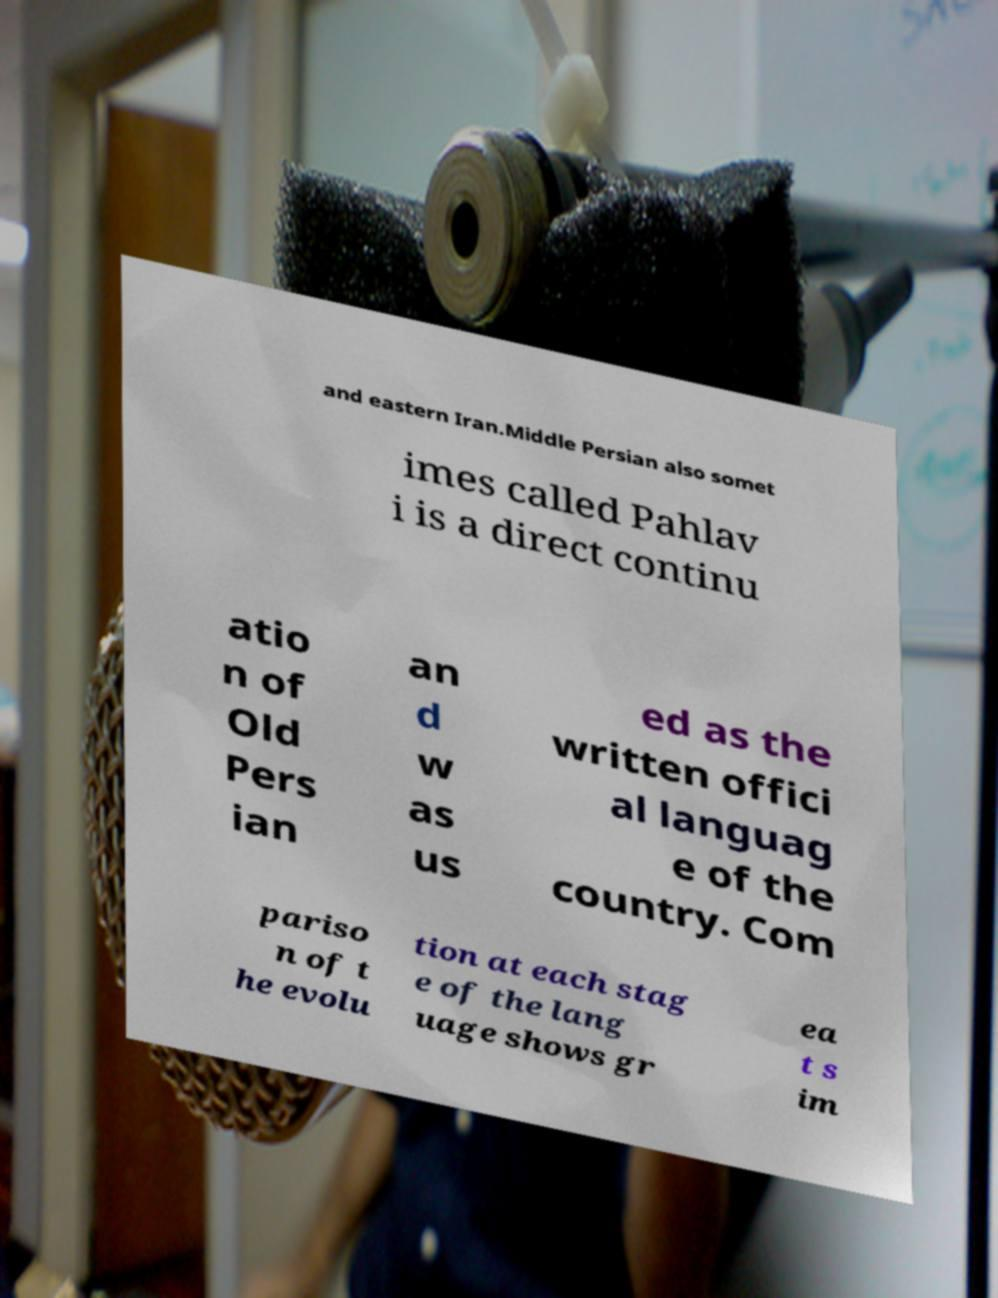I need the written content from this picture converted into text. Can you do that? and eastern Iran.Middle Persian also somet imes called Pahlav i is a direct continu atio n of Old Pers ian an d w as us ed as the written offici al languag e of the country. Com pariso n of t he evolu tion at each stag e of the lang uage shows gr ea t s im 